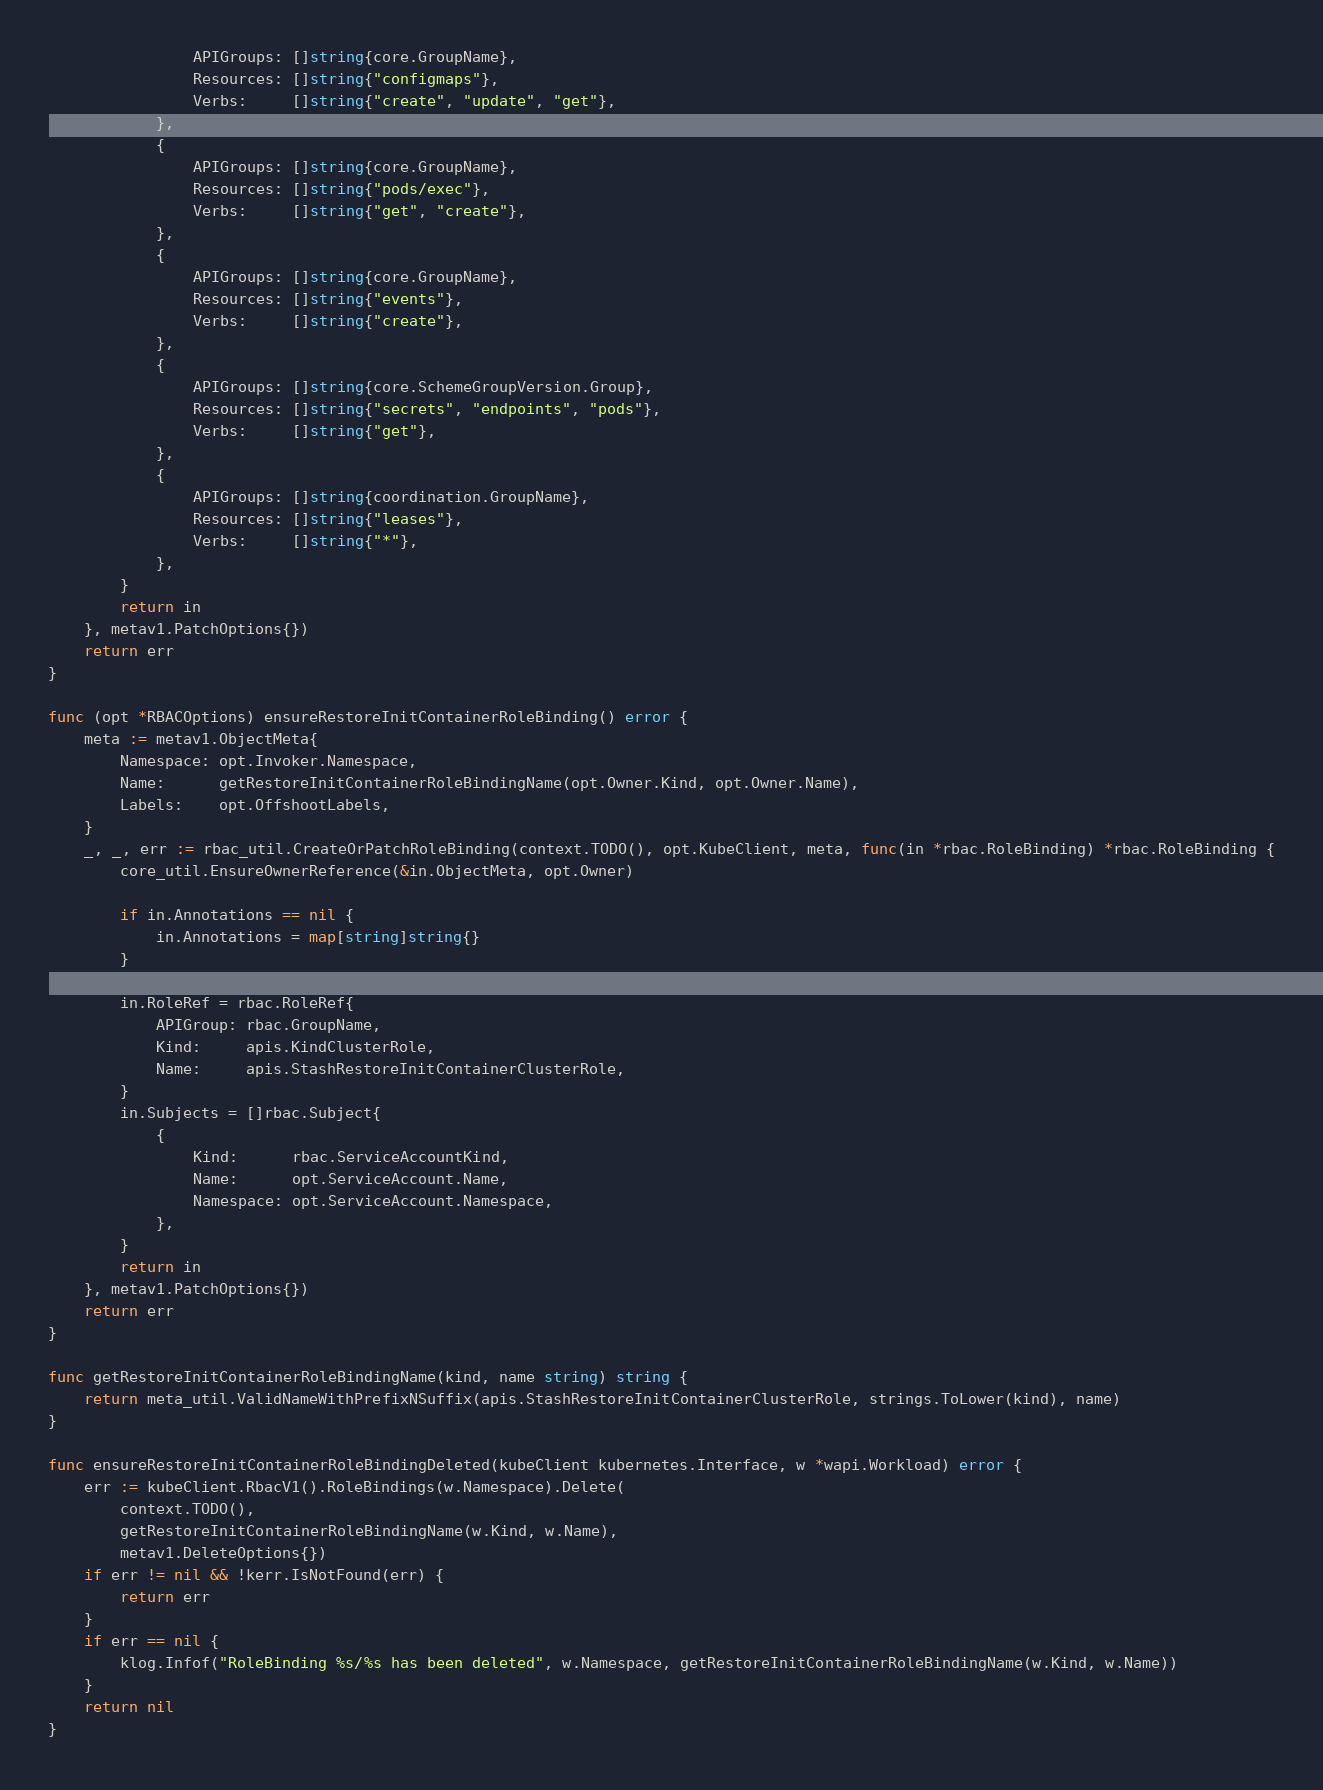Convert code to text. <code><loc_0><loc_0><loc_500><loc_500><_Go_>				APIGroups: []string{core.GroupName},
				Resources: []string{"configmaps"},
				Verbs:     []string{"create", "update", "get"},
			},
			{
				APIGroups: []string{core.GroupName},
				Resources: []string{"pods/exec"},
				Verbs:     []string{"get", "create"},
			},
			{
				APIGroups: []string{core.GroupName},
				Resources: []string{"events"},
				Verbs:     []string{"create"},
			},
			{
				APIGroups: []string{core.SchemeGroupVersion.Group},
				Resources: []string{"secrets", "endpoints", "pods"},
				Verbs:     []string{"get"},
			},
			{
				APIGroups: []string{coordination.GroupName},
				Resources: []string{"leases"},
				Verbs:     []string{"*"},
			},
		}
		return in
	}, metav1.PatchOptions{})
	return err
}

func (opt *RBACOptions) ensureRestoreInitContainerRoleBinding() error {
	meta := metav1.ObjectMeta{
		Namespace: opt.Invoker.Namespace,
		Name:      getRestoreInitContainerRoleBindingName(opt.Owner.Kind, opt.Owner.Name),
		Labels:    opt.OffshootLabels,
	}
	_, _, err := rbac_util.CreateOrPatchRoleBinding(context.TODO(), opt.KubeClient, meta, func(in *rbac.RoleBinding) *rbac.RoleBinding {
		core_util.EnsureOwnerReference(&in.ObjectMeta, opt.Owner)

		if in.Annotations == nil {
			in.Annotations = map[string]string{}
		}

		in.RoleRef = rbac.RoleRef{
			APIGroup: rbac.GroupName,
			Kind:     apis.KindClusterRole,
			Name:     apis.StashRestoreInitContainerClusterRole,
		}
		in.Subjects = []rbac.Subject{
			{
				Kind:      rbac.ServiceAccountKind,
				Name:      opt.ServiceAccount.Name,
				Namespace: opt.ServiceAccount.Namespace,
			},
		}
		return in
	}, metav1.PatchOptions{})
	return err
}

func getRestoreInitContainerRoleBindingName(kind, name string) string {
	return meta_util.ValidNameWithPrefixNSuffix(apis.StashRestoreInitContainerClusterRole, strings.ToLower(kind), name)
}

func ensureRestoreInitContainerRoleBindingDeleted(kubeClient kubernetes.Interface, w *wapi.Workload) error {
	err := kubeClient.RbacV1().RoleBindings(w.Namespace).Delete(
		context.TODO(),
		getRestoreInitContainerRoleBindingName(w.Kind, w.Name),
		metav1.DeleteOptions{})
	if err != nil && !kerr.IsNotFound(err) {
		return err
	}
	if err == nil {
		klog.Infof("RoleBinding %s/%s has been deleted", w.Namespace, getRestoreInitContainerRoleBindingName(w.Kind, w.Name))
	}
	return nil
}
</code> 